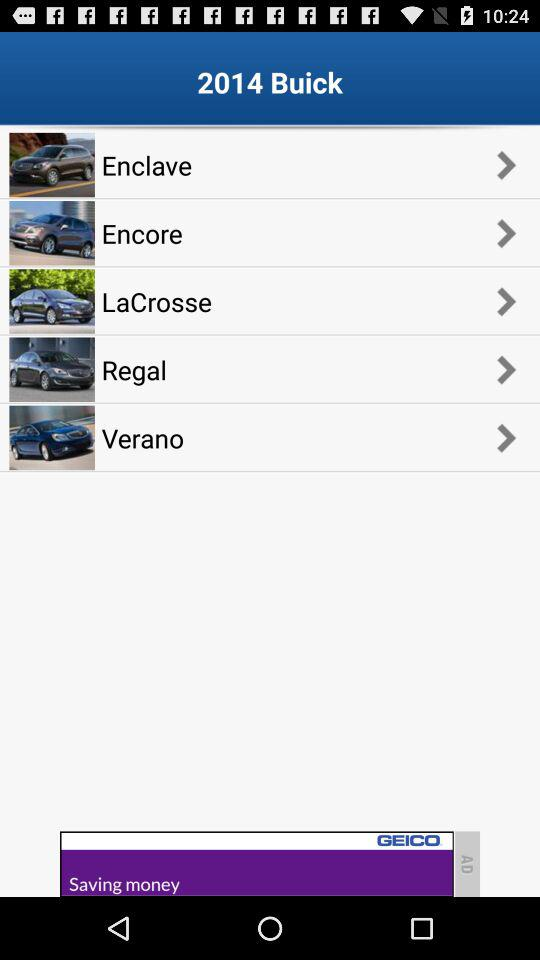What is the year given on the screen? The given year is 2014. 